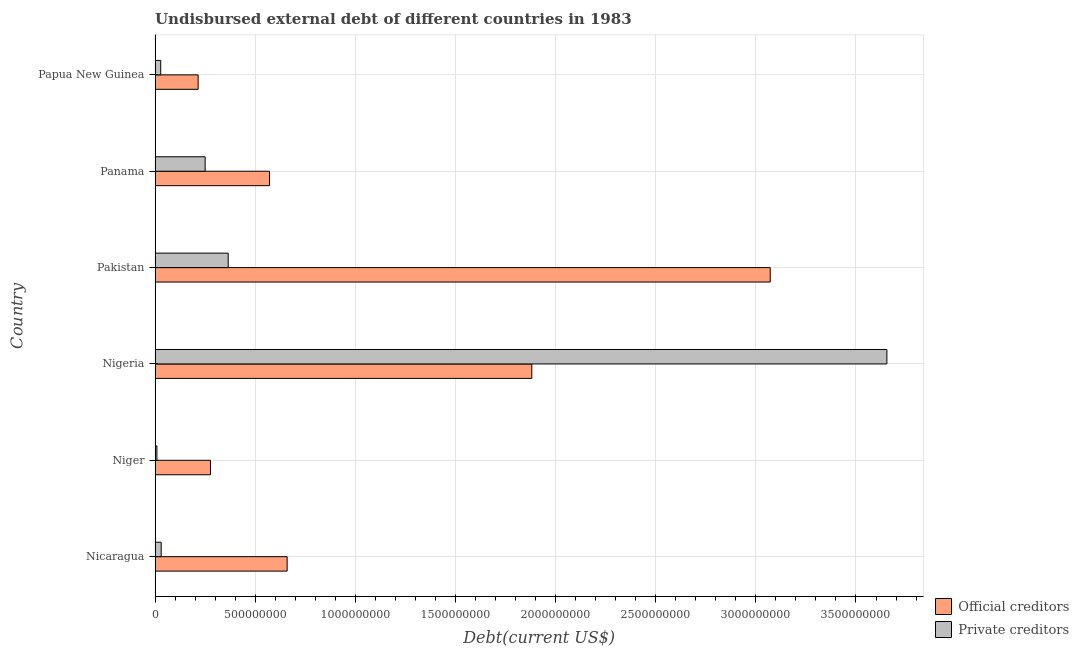How many groups of bars are there?
Provide a short and direct response. 6. Are the number of bars per tick equal to the number of legend labels?
Provide a short and direct response. Yes. How many bars are there on the 6th tick from the top?
Keep it short and to the point. 2. What is the label of the 5th group of bars from the top?
Offer a terse response. Niger. In how many cases, is the number of bars for a given country not equal to the number of legend labels?
Your answer should be very brief. 0. What is the undisbursed external debt of private creditors in Niger?
Offer a very short reply. 9.22e+06. Across all countries, what is the maximum undisbursed external debt of private creditors?
Make the answer very short. 3.65e+09. Across all countries, what is the minimum undisbursed external debt of official creditors?
Make the answer very short. 2.15e+08. In which country was the undisbursed external debt of private creditors maximum?
Provide a short and direct response. Nigeria. In which country was the undisbursed external debt of official creditors minimum?
Your answer should be compact. Papua New Guinea. What is the total undisbursed external debt of official creditors in the graph?
Your response must be concise. 6.68e+09. What is the difference between the undisbursed external debt of official creditors in Panama and that in Papua New Guinea?
Provide a succinct answer. 3.56e+08. What is the difference between the undisbursed external debt of official creditors in Panama and the undisbursed external debt of private creditors in Nigeria?
Offer a very short reply. -3.08e+09. What is the average undisbursed external debt of official creditors per country?
Provide a succinct answer. 1.11e+09. What is the difference between the undisbursed external debt of private creditors and undisbursed external debt of official creditors in Papua New Guinea?
Offer a terse response. -1.87e+08. What is the ratio of the undisbursed external debt of official creditors in Nicaragua to that in Nigeria?
Give a very brief answer. 0.35. What is the difference between the highest and the second highest undisbursed external debt of official creditors?
Offer a very short reply. 1.19e+09. What is the difference between the highest and the lowest undisbursed external debt of private creditors?
Make the answer very short. 3.65e+09. In how many countries, is the undisbursed external debt of official creditors greater than the average undisbursed external debt of official creditors taken over all countries?
Offer a very short reply. 2. Is the sum of the undisbursed external debt of official creditors in Panama and Papua New Guinea greater than the maximum undisbursed external debt of private creditors across all countries?
Make the answer very short. No. What does the 2nd bar from the top in Pakistan represents?
Make the answer very short. Official creditors. What does the 1st bar from the bottom in Niger represents?
Give a very brief answer. Official creditors. How many bars are there?
Your answer should be compact. 12. What is the difference between two consecutive major ticks on the X-axis?
Your response must be concise. 5.00e+08. Are the values on the major ticks of X-axis written in scientific E-notation?
Offer a terse response. No. Does the graph contain grids?
Your answer should be very brief. Yes. Where does the legend appear in the graph?
Offer a terse response. Bottom right. What is the title of the graph?
Offer a terse response. Undisbursed external debt of different countries in 1983. What is the label or title of the X-axis?
Offer a very short reply. Debt(current US$). What is the label or title of the Y-axis?
Offer a very short reply. Country. What is the Debt(current US$) in Official creditors in Nicaragua?
Provide a short and direct response. 6.60e+08. What is the Debt(current US$) in Private creditors in Nicaragua?
Make the answer very short. 3.06e+07. What is the Debt(current US$) of Official creditors in Niger?
Your response must be concise. 2.77e+08. What is the Debt(current US$) of Private creditors in Niger?
Your answer should be very brief. 9.22e+06. What is the Debt(current US$) of Official creditors in Nigeria?
Offer a very short reply. 1.88e+09. What is the Debt(current US$) in Private creditors in Nigeria?
Give a very brief answer. 3.65e+09. What is the Debt(current US$) of Official creditors in Pakistan?
Make the answer very short. 3.07e+09. What is the Debt(current US$) of Private creditors in Pakistan?
Provide a succinct answer. 3.65e+08. What is the Debt(current US$) in Official creditors in Panama?
Keep it short and to the point. 5.72e+08. What is the Debt(current US$) of Private creditors in Panama?
Ensure brevity in your answer.  2.50e+08. What is the Debt(current US$) of Official creditors in Papua New Guinea?
Keep it short and to the point. 2.15e+08. What is the Debt(current US$) in Private creditors in Papua New Guinea?
Your response must be concise. 2.82e+07. Across all countries, what is the maximum Debt(current US$) in Official creditors?
Your answer should be very brief. 3.07e+09. Across all countries, what is the maximum Debt(current US$) in Private creditors?
Offer a very short reply. 3.65e+09. Across all countries, what is the minimum Debt(current US$) in Official creditors?
Offer a terse response. 2.15e+08. Across all countries, what is the minimum Debt(current US$) of Private creditors?
Make the answer very short. 9.22e+06. What is the total Debt(current US$) in Official creditors in the graph?
Your response must be concise. 6.68e+09. What is the total Debt(current US$) of Private creditors in the graph?
Keep it short and to the point. 4.34e+09. What is the difference between the Debt(current US$) of Official creditors in Nicaragua and that in Niger?
Keep it short and to the point. 3.83e+08. What is the difference between the Debt(current US$) in Private creditors in Nicaragua and that in Niger?
Make the answer very short. 2.14e+07. What is the difference between the Debt(current US$) of Official creditors in Nicaragua and that in Nigeria?
Your response must be concise. -1.22e+09. What is the difference between the Debt(current US$) in Private creditors in Nicaragua and that in Nigeria?
Ensure brevity in your answer.  -3.62e+09. What is the difference between the Debt(current US$) in Official creditors in Nicaragua and that in Pakistan?
Your answer should be very brief. -2.41e+09. What is the difference between the Debt(current US$) in Private creditors in Nicaragua and that in Pakistan?
Your response must be concise. -3.35e+08. What is the difference between the Debt(current US$) in Official creditors in Nicaragua and that in Panama?
Offer a terse response. 8.79e+07. What is the difference between the Debt(current US$) in Private creditors in Nicaragua and that in Panama?
Offer a terse response. -2.20e+08. What is the difference between the Debt(current US$) of Official creditors in Nicaragua and that in Papua New Guinea?
Offer a very short reply. 4.44e+08. What is the difference between the Debt(current US$) in Private creditors in Nicaragua and that in Papua New Guinea?
Your response must be concise. 2.37e+06. What is the difference between the Debt(current US$) in Official creditors in Niger and that in Nigeria?
Your answer should be compact. -1.60e+09. What is the difference between the Debt(current US$) in Private creditors in Niger and that in Nigeria?
Provide a succinct answer. -3.65e+09. What is the difference between the Debt(current US$) of Official creditors in Niger and that in Pakistan?
Provide a succinct answer. -2.80e+09. What is the difference between the Debt(current US$) of Private creditors in Niger and that in Pakistan?
Provide a succinct answer. -3.56e+08. What is the difference between the Debt(current US$) of Official creditors in Niger and that in Panama?
Provide a succinct answer. -2.95e+08. What is the difference between the Debt(current US$) of Private creditors in Niger and that in Panama?
Ensure brevity in your answer.  -2.41e+08. What is the difference between the Debt(current US$) of Official creditors in Niger and that in Papua New Guinea?
Ensure brevity in your answer.  6.16e+07. What is the difference between the Debt(current US$) in Private creditors in Niger and that in Papua New Guinea?
Ensure brevity in your answer.  -1.90e+07. What is the difference between the Debt(current US$) of Official creditors in Nigeria and that in Pakistan?
Make the answer very short. -1.19e+09. What is the difference between the Debt(current US$) of Private creditors in Nigeria and that in Pakistan?
Your answer should be compact. 3.29e+09. What is the difference between the Debt(current US$) of Official creditors in Nigeria and that in Panama?
Offer a very short reply. 1.31e+09. What is the difference between the Debt(current US$) in Private creditors in Nigeria and that in Panama?
Keep it short and to the point. 3.40e+09. What is the difference between the Debt(current US$) in Official creditors in Nigeria and that in Papua New Guinea?
Keep it short and to the point. 1.67e+09. What is the difference between the Debt(current US$) in Private creditors in Nigeria and that in Papua New Guinea?
Provide a short and direct response. 3.63e+09. What is the difference between the Debt(current US$) in Official creditors in Pakistan and that in Panama?
Provide a short and direct response. 2.50e+09. What is the difference between the Debt(current US$) in Private creditors in Pakistan and that in Panama?
Ensure brevity in your answer.  1.15e+08. What is the difference between the Debt(current US$) in Official creditors in Pakistan and that in Papua New Guinea?
Give a very brief answer. 2.86e+09. What is the difference between the Debt(current US$) of Private creditors in Pakistan and that in Papua New Guinea?
Provide a short and direct response. 3.37e+08. What is the difference between the Debt(current US$) of Official creditors in Panama and that in Papua New Guinea?
Give a very brief answer. 3.56e+08. What is the difference between the Debt(current US$) of Private creditors in Panama and that in Papua New Guinea?
Make the answer very short. 2.22e+08. What is the difference between the Debt(current US$) in Official creditors in Nicaragua and the Debt(current US$) in Private creditors in Niger?
Offer a terse response. 6.50e+08. What is the difference between the Debt(current US$) of Official creditors in Nicaragua and the Debt(current US$) of Private creditors in Nigeria?
Make the answer very short. -2.99e+09. What is the difference between the Debt(current US$) in Official creditors in Nicaragua and the Debt(current US$) in Private creditors in Pakistan?
Provide a succinct answer. 2.94e+08. What is the difference between the Debt(current US$) in Official creditors in Nicaragua and the Debt(current US$) in Private creditors in Panama?
Provide a short and direct response. 4.09e+08. What is the difference between the Debt(current US$) in Official creditors in Nicaragua and the Debt(current US$) in Private creditors in Papua New Guinea?
Keep it short and to the point. 6.31e+08. What is the difference between the Debt(current US$) in Official creditors in Niger and the Debt(current US$) in Private creditors in Nigeria?
Offer a terse response. -3.38e+09. What is the difference between the Debt(current US$) of Official creditors in Niger and the Debt(current US$) of Private creditors in Pakistan?
Your response must be concise. -8.86e+07. What is the difference between the Debt(current US$) in Official creditors in Niger and the Debt(current US$) in Private creditors in Panama?
Your answer should be compact. 2.65e+07. What is the difference between the Debt(current US$) of Official creditors in Niger and the Debt(current US$) of Private creditors in Papua New Guinea?
Provide a succinct answer. 2.48e+08. What is the difference between the Debt(current US$) of Official creditors in Nigeria and the Debt(current US$) of Private creditors in Pakistan?
Provide a succinct answer. 1.52e+09. What is the difference between the Debt(current US$) of Official creditors in Nigeria and the Debt(current US$) of Private creditors in Panama?
Make the answer very short. 1.63e+09. What is the difference between the Debt(current US$) of Official creditors in Nigeria and the Debt(current US$) of Private creditors in Papua New Guinea?
Give a very brief answer. 1.85e+09. What is the difference between the Debt(current US$) in Official creditors in Pakistan and the Debt(current US$) in Private creditors in Panama?
Your answer should be very brief. 2.82e+09. What is the difference between the Debt(current US$) in Official creditors in Pakistan and the Debt(current US$) in Private creditors in Papua New Guinea?
Offer a terse response. 3.04e+09. What is the difference between the Debt(current US$) of Official creditors in Panama and the Debt(current US$) of Private creditors in Papua New Guinea?
Your answer should be compact. 5.43e+08. What is the average Debt(current US$) of Official creditors per country?
Your response must be concise. 1.11e+09. What is the average Debt(current US$) in Private creditors per country?
Ensure brevity in your answer.  7.23e+08. What is the difference between the Debt(current US$) of Official creditors and Debt(current US$) of Private creditors in Nicaragua?
Your answer should be compact. 6.29e+08. What is the difference between the Debt(current US$) of Official creditors and Debt(current US$) of Private creditors in Niger?
Ensure brevity in your answer.  2.67e+08. What is the difference between the Debt(current US$) of Official creditors and Debt(current US$) of Private creditors in Nigeria?
Your answer should be very brief. -1.77e+09. What is the difference between the Debt(current US$) in Official creditors and Debt(current US$) in Private creditors in Pakistan?
Offer a terse response. 2.71e+09. What is the difference between the Debt(current US$) of Official creditors and Debt(current US$) of Private creditors in Panama?
Your answer should be very brief. 3.21e+08. What is the difference between the Debt(current US$) of Official creditors and Debt(current US$) of Private creditors in Papua New Guinea?
Provide a short and direct response. 1.87e+08. What is the ratio of the Debt(current US$) of Official creditors in Nicaragua to that in Niger?
Provide a succinct answer. 2.38. What is the ratio of the Debt(current US$) of Private creditors in Nicaragua to that in Niger?
Offer a very short reply. 3.32. What is the ratio of the Debt(current US$) of Official creditors in Nicaragua to that in Nigeria?
Provide a short and direct response. 0.35. What is the ratio of the Debt(current US$) of Private creditors in Nicaragua to that in Nigeria?
Make the answer very short. 0.01. What is the ratio of the Debt(current US$) of Official creditors in Nicaragua to that in Pakistan?
Keep it short and to the point. 0.21. What is the ratio of the Debt(current US$) of Private creditors in Nicaragua to that in Pakistan?
Keep it short and to the point. 0.08. What is the ratio of the Debt(current US$) of Official creditors in Nicaragua to that in Panama?
Offer a very short reply. 1.15. What is the ratio of the Debt(current US$) of Private creditors in Nicaragua to that in Panama?
Provide a short and direct response. 0.12. What is the ratio of the Debt(current US$) in Official creditors in Nicaragua to that in Papua New Guinea?
Offer a terse response. 3.07. What is the ratio of the Debt(current US$) of Private creditors in Nicaragua to that in Papua New Guinea?
Provide a short and direct response. 1.08. What is the ratio of the Debt(current US$) in Official creditors in Niger to that in Nigeria?
Offer a very short reply. 0.15. What is the ratio of the Debt(current US$) of Private creditors in Niger to that in Nigeria?
Your answer should be very brief. 0. What is the ratio of the Debt(current US$) in Official creditors in Niger to that in Pakistan?
Provide a short and direct response. 0.09. What is the ratio of the Debt(current US$) in Private creditors in Niger to that in Pakistan?
Offer a terse response. 0.03. What is the ratio of the Debt(current US$) in Official creditors in Niger to that in Panama?
Provide a succinct answer. 0.48. What is the ratio of the Debt(current US$) in Private creditors in Niger to that in Panama?
Offer a terse response. 0.04. What is the ratio of the Debt(current US$) in Official creditors in Niger to that in Papua New Guinea?
Make the answer very short. 1.29. What is the ratio of the Debt(current US$) of Private creditors in Niger to that in Papua New Guinea?
Ensure brevity in your answer.  0.33. What is the ratio of the Debt(current US$) in Official creditors in Nigeria to that in Pakistan?
Your response must be concise. 0.61. What is the ratio of the Debt(current US$) in Private creditors in Nigeria to that in Pakistan?
Offer a terse response. 10. What is the ratio of the Debt(current US$) in Official creditors in Nigeria to that in Panama?
Offer a terse response. 3.29. What is the ratio of the Debt(current US$) in Private creditors in Nigeria to that in Panama?
Keep it short and to the point. 14.61. What is the ratio of the Debt(current US$) of Official creditors in Nigeria to that in Papua New Guinea?
Give a very brief answer. 8.75. What is the ratio of the Debt(current US$) of Private creditors in Nigeria to that in Papua New Guinea?
Make the answer very short. 129.49. What is the ratio of the Debt(current US$) in Official creditors in Pakistan to that in Panama?
Offer a very short reply. 5.37. What is the ratio of the Debt(current US$) of Private creditors in Pakistan to that in Panama?
Make the answer very short. 1.46. What is the ratio of the Debt(current US$) of Official creditors in Pakistan to that in Papua New Guinea?
Give a very brief answer. 14.28. What is the ratio of the Debt(current US$) of Private creditors in Pakistan to that in Papua New Guinea?
Provide a short and direct response. 12.94. What is the ratio of the Debt(current US$) in Official creditors in Panama to that in Papua New Guinea?
Your answer should be compact. 2.66. What is the ratio of the Debt(current US$) of Private creditors in Panama to that in Papua New Guinea?
Your answer should be very brief. 8.87. What is the difference between the highest and the second highest Debt(current US$) in Official creditors?
Provide a short and direct response. 1.19e+09. What is the difference between the highest and the second highest Debt(current US$) in Private creditors?
Your answer should be compact. 3.29e+09. What is the difference between the highest and the lowest Debt(current US$) of Official creditors?
Offer a terse response. 2.86e+09. What is the difference between the highest and the lowest Debt(current US$) in Private creditors?
Keep it short and to the point. 3.65e+09. 